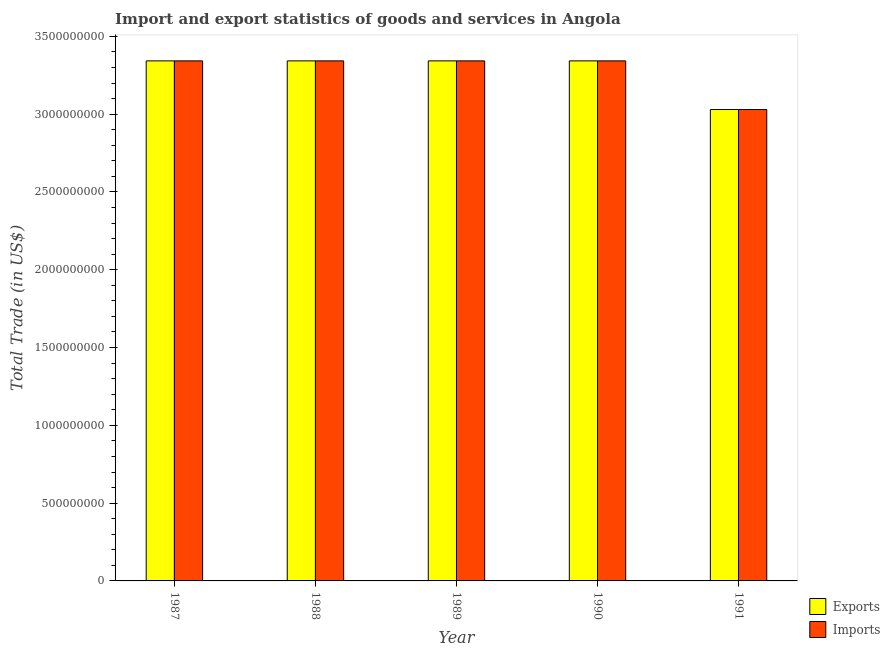How many different coloured bars are there?
Make the answer very short. 2. How many groups of bars are there?
Keep it short and to the point. 5. How many bars are there on the 5th tick from the left?
Give a very brief answer. 2. How many bars are there on the 1st tick from the right?
Provide a succinct answer. 2. What is the label of the 2nd group of bars from the left?
Ensure brevity in your answer.  1988. What is the export of goods and services in 1988?
Ensure brevity in your answer.  3.34e+09. Across all years, what is the maximum imports of goods and services?
Offer a very short reply. 3.34e+09. Across all years, what is the minimum imports of goods and services?
Give a very brief answer. 3.03e+09. In which year was the export of goods and services maximum?
Make the answer very short. 1987. In which year was the export of goods and services minimum?
Provide a short and direct response. 1991. What is the total export of goods and services in the graph?
Your answer should be compact. 1.64e+1. What is the difference between the export of goods and services in 1988 and that in 1991?
Ensure brevity in your answer.  3.13e+08. What is the average imports of goods and services per year?
Offer a terse response. 3.28e+09. In the year 1989, what is the difference between the export of goods and services and imports of goods and services?
Provide a succinct answer. 0. In how many years, is the export of goods and services greater than 500000000 US$?
Give a very brief answer. 5. What is the ratio of the export of goods and services in 1988 to that in 1989?
Give a very brief answer. 1. Is the difference between the imports of goods and services in 1990 and 1991 greater than the difference between the export of goods and services in 1990 and 1991?
Offer a very short reply. No. What is the difference between the highest and the lowest export of goods and services?
Offer a very short reply. 3.13e+08. In how many years, is the export of goods and services greater than the average export of goods and services taken over all years?
Ensure brevity in your answer.  4. What does the 1st bar from the left in 1989 represents?
Offer a terse response. Exports. What does the 1st bar from the right in 1988 represents?
Your answer should be very brief. Imports. Are all the bars in the graph horizontal?
Your response must be concise. No. What is the difference between two consecutive major ticks on the Y-axis?
Ensure brevity in your answer.  5.00e+08. Does the graph contain grids?
Make the answer very short. No. How many legend labels are there?
Your response must be concise. 2. How are the legend labels stacked?
Your response must be concise. Vertical. What is the title of the graph?
Your answer should be compact. Import and export statistics of goods and services in Angola. What is the label or title of the Y-axis?
Your answer should be very brief. Total Trade (in US$). What is the Total Trade (in US$) of Exports in 1987?
Ensure brevity in your answer.  3.34e+09. What is the Total Trade (in US$) in Imports in 1987?
Your answer should be compact. 3.34e+09. What is the Total Trade (in US$) of Exports in 1988?
Give a very brief answer. 3.34e+09. What is the Total Trade (in US$) in Imports in 1988?
Your answer should be very brief. 3.34e+09. What is the Total Trade (in US$) in Exports in 1989?
Give a very brief answer. 3.34e+09. What is the Total Trade (in US$) of Imports in 1989?
Ensure brevity in your answer.  3.34e+09. What is the Total Trade (in US$) in Exports in 1990?
Ensure brevity in your answer.  3.34e+09. What is the Total Trade (in US$) in Imports in 1990?
Provide a succinct answer. 3.34e+09. What is the Total Trade (in US$) in Exports in 1991?
Give a very brief answer. 3.03e+09. What is the Total Trade (in US$) of Imports in 1991?
Make the answer very short. 3.03e+09. Across all years, what is the maximum Total Trade (in US$) of Exports?
Provide a succinct answer. 3.34e+09. Across all years, what is the maximum Total Trade (in US$) in Imports?
Provide a short and direct response. 3.34e+09. Across all years, what is the minimum Total Trade (in US$) of Exports?
Give a very brief answer. 3.03e+09. Across all years, what is the minimum Total Trade (in US$) of Imports?
Your answer should be compact. 3.03e+09. What is the total Total Trade (in US$) in Exports in the graph?
Your answer should be very brief. 1.64e+1. What is the total Total Trade (in US$) of Imports in the graph?
Your answer should be very brief. 1.64e+1. What is the difference between the Total Trade (in US$) in Imports in 1987 and that in 1989?
Keep it short and to the point. 0. What is the difference between the Total Trade (in US$) in Exports in 1987 and that in 1990?
Ensure brevity in your answer.  0. What is the difference between the Total Trade (in US$) in Exports in 1987 and that in 1991?
Provide a short and direct response. 3.13e+08. What is the difference between the Total Trade (in US$) of Imports in 1987 and that in 1991?
Your answer should be compact. 3.13e+08. What is the difference between the Total Trade (in US$) in Imports in 1988 and that in 1989?
Give a very brief answer. 0. What is the difference between the Total Trade (in US$) of Exports in 1988 and that in 1990?
Offer a very short reply. 0. What is the difference between the Total Trade (in US$) in Imports in 1988 and that in 1990?
Keep it short and to the point. 0. What is the difference between the Total Trade (in US$) in Exports in 1988 and that in 1991?
Provide a succinct answer. 3.13e+08. What is the difference between the Total Trade (in US$) in Imports in 1988 and that in 1991?
Provide a short and direct response. 3.13e+08. What is the difference between the Total Trade (in US$) in Exports in 1989 and that in 1990?
Provide a short and direct response. 0. What is the difference between the Total Trade (in US$) of Exports in 1989 and that in 1991?
Offer a terse response. 3.13e+08. What is the difference between the Total Trade (in US$) of Imports in 1989 and that in 1991?
Your answer should be compact. 3.13e+08. What is the difference between the Total Trade (in US$) in Exports in 1990 and that in 1991?
Give a very brief answer. 3.13e+08. What is the difference between the Total Trade (in US$) of Imports in 1990 and that in 1991?
Make the answer very short. 3.13e+08. What is the difference between the Total Trade (in US$) of Exports in 1987 and the Total Trade (in US$) of Imports in 1989?
Make the answer very short. 0. What is the difference between the Total Trade (in US$) in Exports in 1987 and the Total Trade (in US$) in Imports in 1990?
Your response must be concise. 0. What is the difference between the Total Trade (in US$) of Exports in 1987 and the Total Trade (in US$) of Imports in 1991?
Provide a short and direct response. 3.13e+08. What is the difference between the Total Trade (in US$) in Exports in 1988 and the Total Trade (in US$) in Imports in 1991?
Offer a terse response. 3.13e+08. What is the difference between the Total Trade (in US$) in Exports in 1989 and the Total Trade (in US$) in Imports in 1991?
Your response must be concise. 3.13e+08. What is the difference between the Total Trade (in US$) of Exports in 1990 and the Total Trade (in US$) of Imports in 1991?
Your response must be concise. 3.13e+08. What is the average Total Trade (in US$) in Exports per year?
Keep it short and to the point. 3.28e+09. What is the average Total Trade (in US$) in Imports per year?
Your response must be concise. 3.28e+09. In the year 1989, what is the difference between the Total Trade (in US$) of Exports and Total Trade (in US$) of Imports?
Provide a short and direct response. 0. What is the ratio of the Total Trade (in US$) in Exports in 1987 to that in 1988?
Give a very brief answer. 1. What is the ratio of the Total Trade (in US$) of Exports in 1987 to that in 1990?
Make the answer very short. 1. What is the ratio of the Total Trade (in US$) of Imports in 1987 to that in 1990?
Your answer should be very brief. 1. What is the ratio of the Total Trade (in US$) of Exports in 1987 to that in 1991?
Give a very brief answer. 1.1. What is the ratio of the Total Trade (in US$) of Imports in 1987 to that in 1991?
Keep it short and to the point. 1.1. What is the ratio of the Total Trade (in US$) of Exports in 1988 to that in 1989?
Ensure brevity in your answer.  1. What is the ratio of the Total Trade (in US$) in Imports in 1988 to that in 1990?
Your answer should be compact. 1. What is the ratio of the Total Trade (in US$) in Exports in 1988 to that in 1991?
Your response must be concise. 1.1. What is the ratio of the Total Trade (in US$) of Imports in 1988 to that in 1991?
Your response must be concise. 1.1. What is the ratio of the Total Trade (in US$) in Imports in 1989 to that in 1990?
Provide a succinct answer. 1. What is the ratio of the Total Trade (in US$) of Exports in 1989 to that in 1991?
Give a very brief answer. 1.1. What is the ratio of the Total Trade (in US$) of Imports in 1989 to that in 1991?
Your answer should be compact. 1.1. What is the ratio of the Total Trade (in US$) in Exports in 1990 to that in 1991?
Keep it short and to the point. 1.1. What is the ratio of the Total Trade (in US$) in Imports in 1990 to that in 1991?
Your answer should be compact. 1.1. What is the difference between the highest and the second highest Total Trade (in US$) in Exports?
Offer a terse response. 0. What is the difference between the highest and the second highest Total Trade (in US$) in Imports?
Give a very brief answer. 0. What is the difference between the highest and the lowest Total Trade (in US$) of Exports?
Provide a short and direct response. 3.13e+08. What is the difference between the highest and the lowest Total Trade (in US$) of Imports?
Offer a terse response. 3.13e+08. 